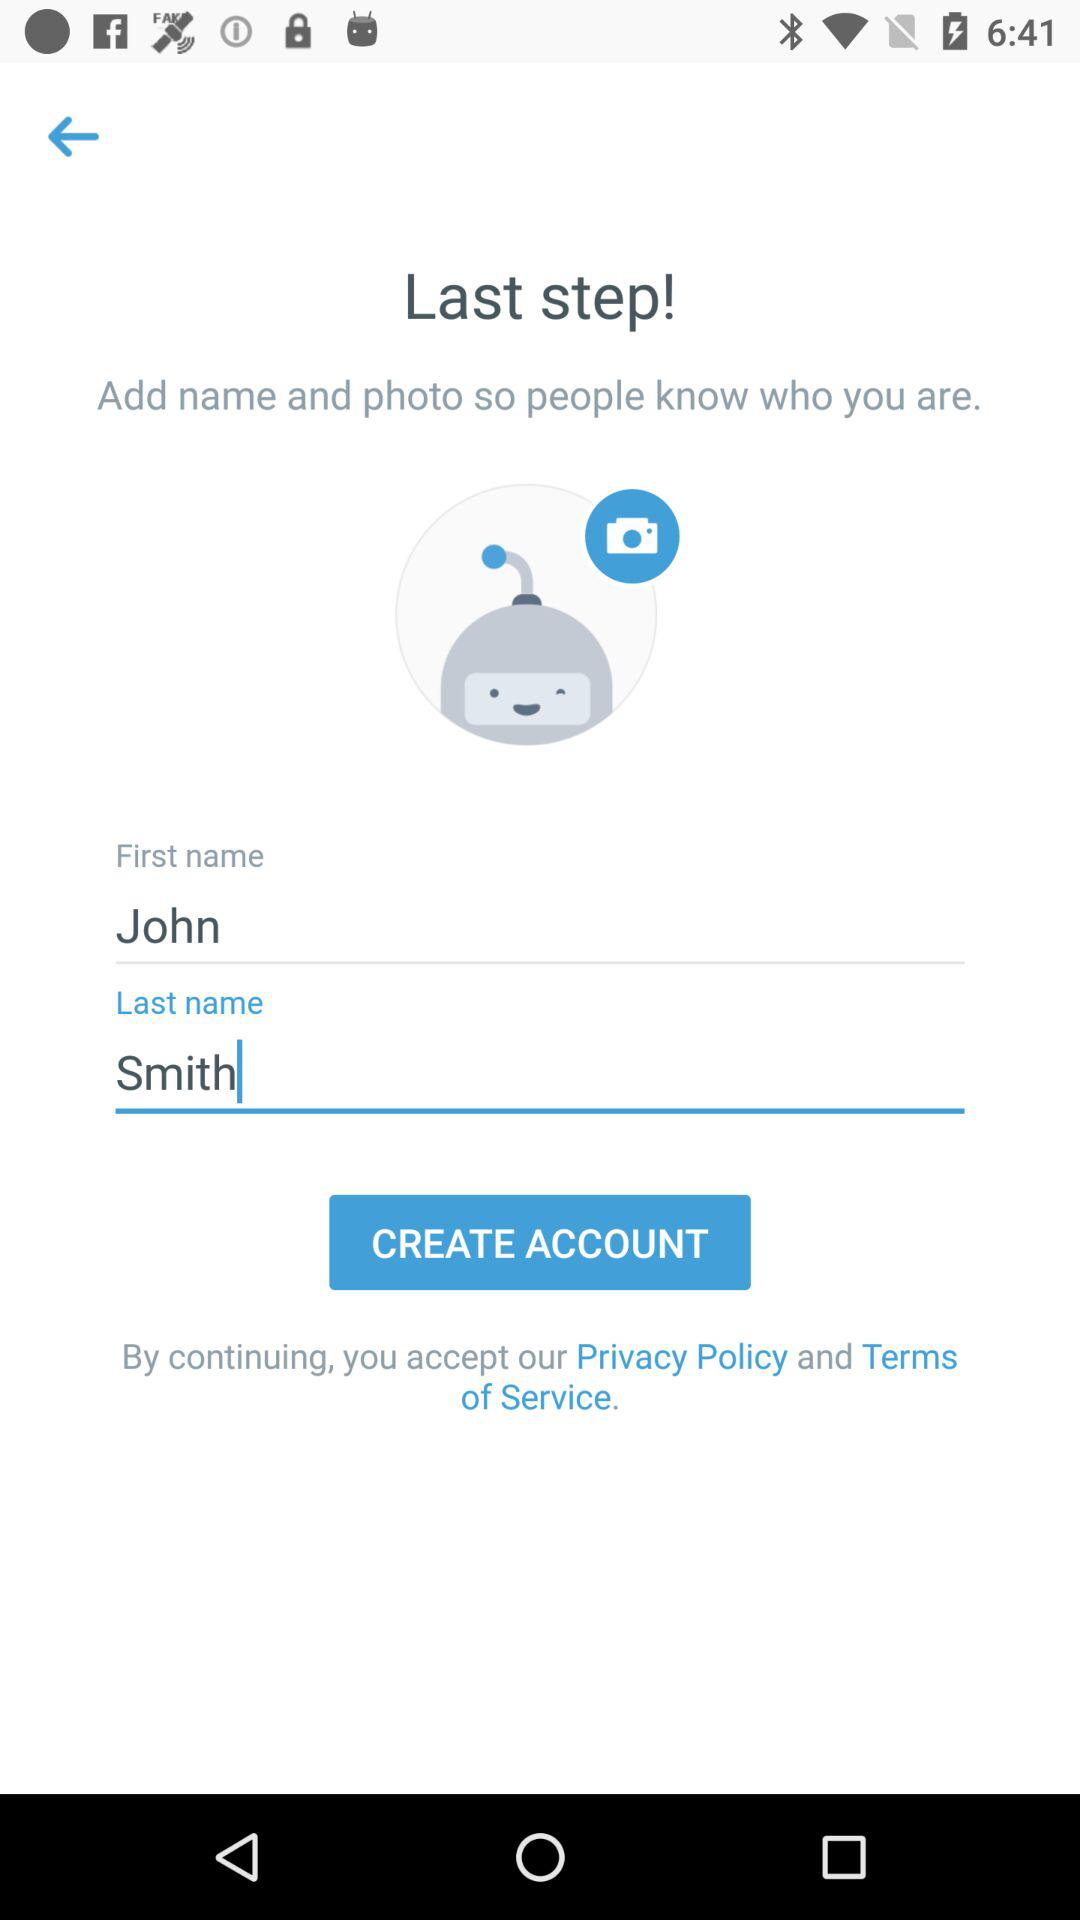What is the first name? The first name is John. 